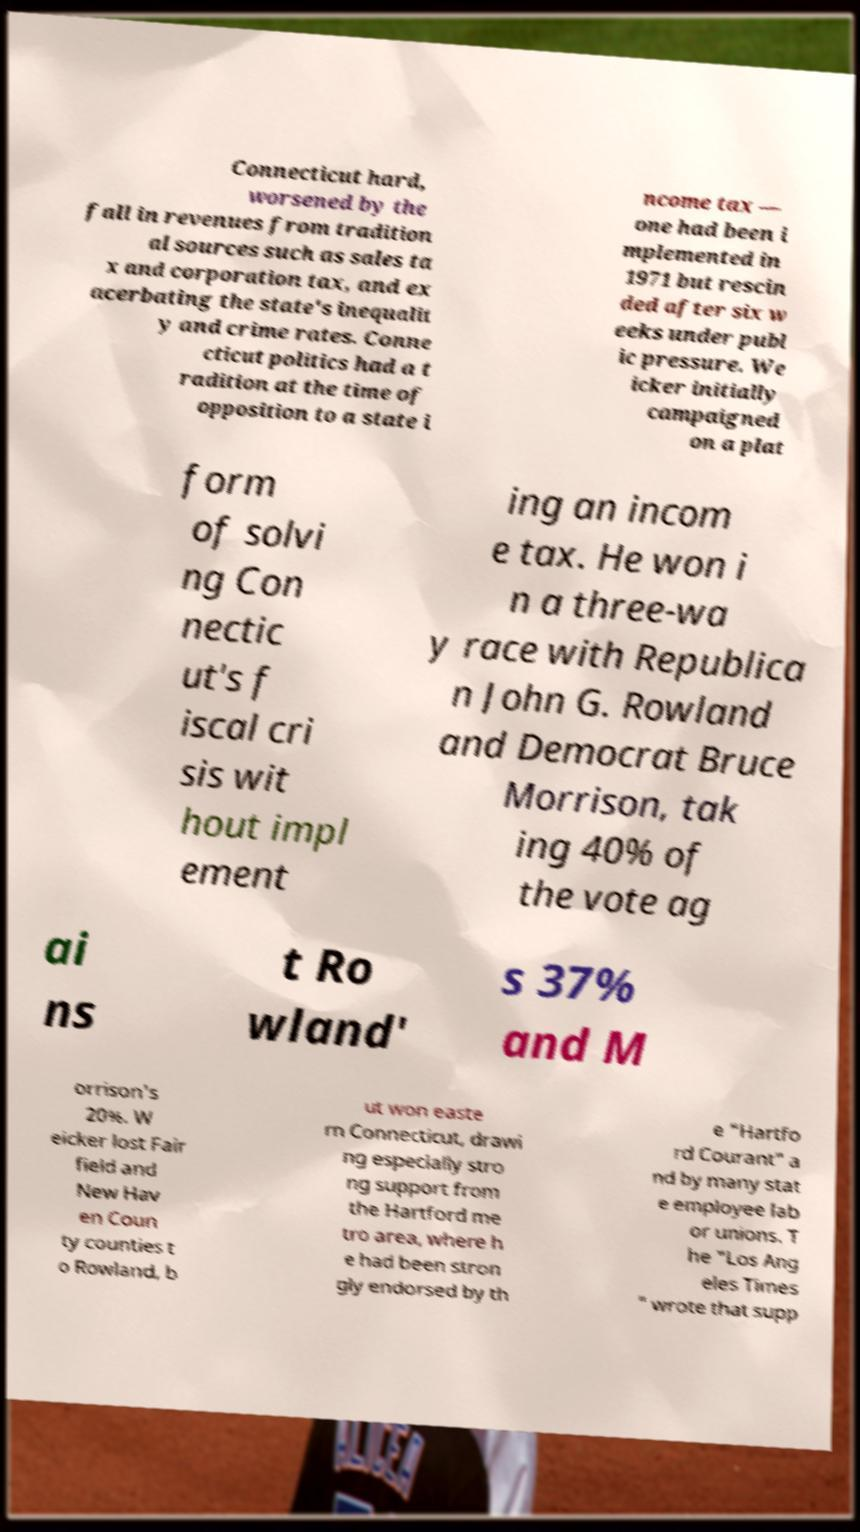I need the written content from this picture converted into text. Can you do that? Connecticut hard, worsened by the fall in revenues from tradition al sources such as sales ta x and corporation tax, and ex acerbating the state's inequalit y and crime rates. Conne cticut politics had a t radition at the time of opposition to a state i ncome tax — one had been i mplemented in 1971 but rescin ded after six w eeks under publ ic pressure. We icker initially campaigned on a plat form of solvi ng Con nectic ut's f iscal cri sis wit hout impl ement ing an incom e tax. He won i n a three-wa y race with Republica n John G. Rowland and Democrat Bruce Morrison, tak ing 40% of the vote ag ai ns t Ro wland' s 37% and M orrison's 20%. W eicker lost Fair field and New Hav en Coun ty counties t o Rowland, b ut won easte rn Connecticut, drawi ng especially stro ng support from the Hartford me tro area, where h e had been stron gly endorsed by th e "Hartfo rd Courant" a nd by many stat e employee lab or unions. T he "Los Ang eles Times " wrote that supp 